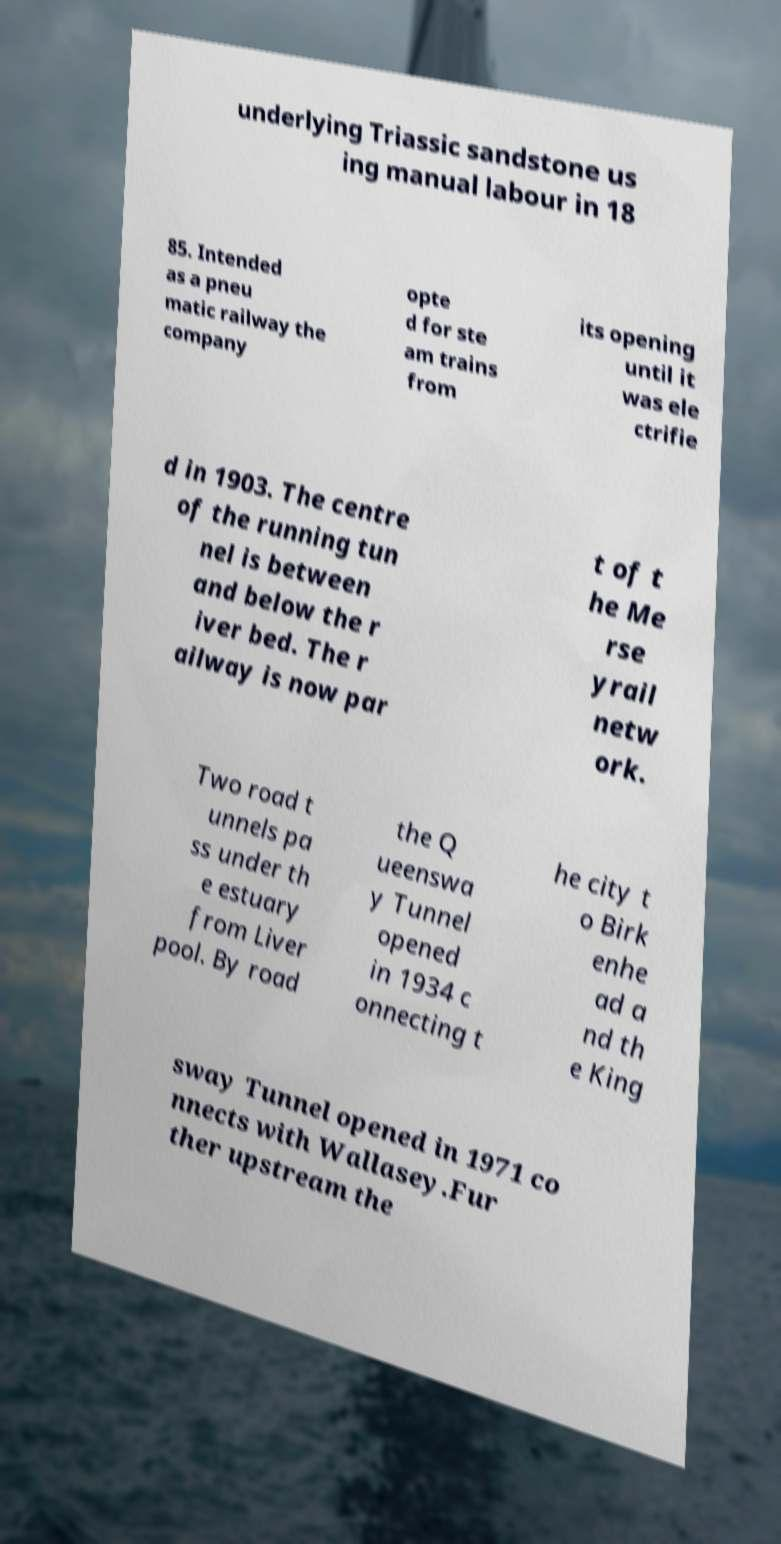There's text embedded in this image that I need extracted. Can you transcribe it verbatim? underlying Triassic sandstone us ing manual labour in 18 85. Intended as a pneu matic railway the company opte d for ste am trains from its opening until it was ele ctrifie d in 1903. The centre of the running tun nel is between and below the r iver bed. The r ailway is now par t of t he Me rse yrail netw ork. Two road t unnels pa ss under th e estuary from Liver pool. By road the Q ueenswa y Tunnel opened in 1934 c onnecting t he city t o Birk enhe ad a nd th e King sway Tunnel opened in 1971 co nnects with Wallasey.Fur ther upstream the 